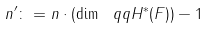Convert formula to latex. <formula><loc_0><loc_0><loc_500><loc_500>n ^ { \prime } \colon = n \cdot ( \dim _ { \ } q q H ^ { * } ( F ) ) - 1</formula> 